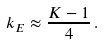<formula> <loc_0><loc_0><loc_500><loc_500>k _ { E } \approx \frac { K - 1 } { 4 } \, .</formula> 